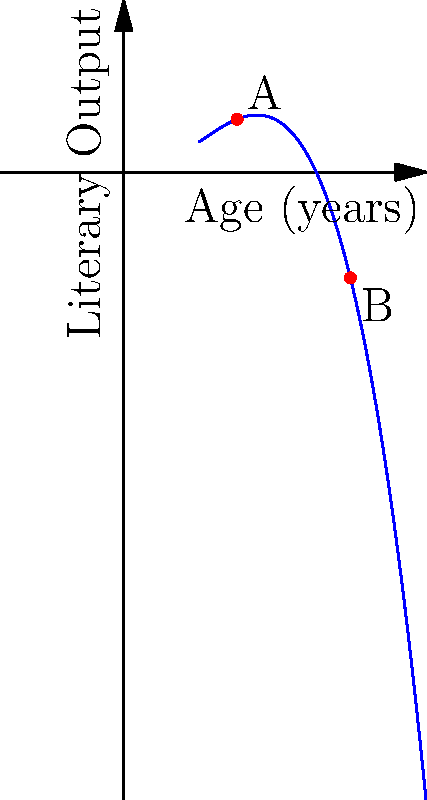The graph represents the relationship between an author's age and their literary output. Point A represents the author at age 30, and point B represents the same author at age 60. Based on this polynomial curve, what can you conclude about the author's productivity between these two points in their career? To analyze the author's productivity between points A and B, we need to examine the shape of the curve:

1. Identify the curve's behavior: The curve is a cubic polynomial with a single inflection point.

2. Observe the slope:
   - From point A (age 30) to the inflection point: The slope is positive and increasing.
   - From the inflection point to point B (age 60): The slope is positive but decreasing.

3. Interpret the slope:
   - A positive slope indicates an increase in literary output.
   - An increasing slope (from A to inflection) suggests accelerating productivity.
   - A decreasing slope (from inflection to B) suggests decelerating productivity.

4. Compare points A and B:
   - Point B is higher on the y-axis than point A, indicating higher overall output at age 60 compared to age 30.

5. Conclusion:
   The author's literary output increased from age 30 to 60, with a period of accelerating productivity followed by a period of decelerating productivity.
Answer: Increased output with initial acceleration, then deceleration 